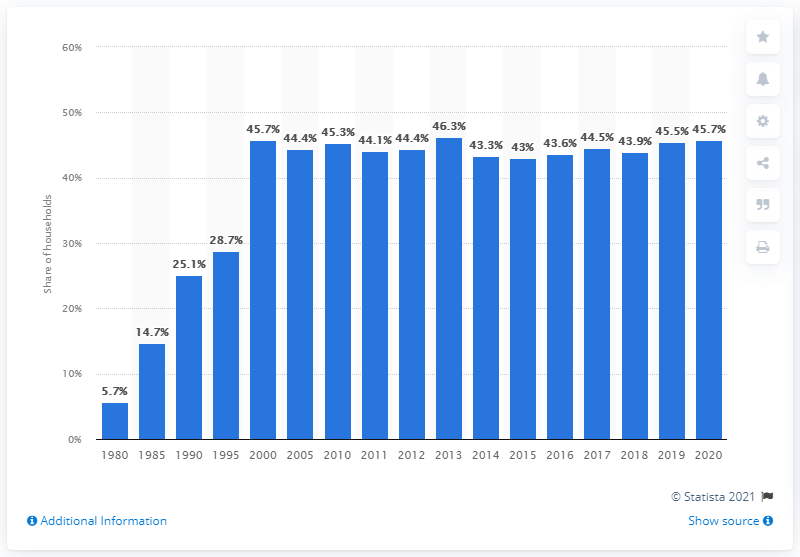Point out several critical features in this image. In 2020, approximately 45.7% of households in the United States owned mutual funds. 